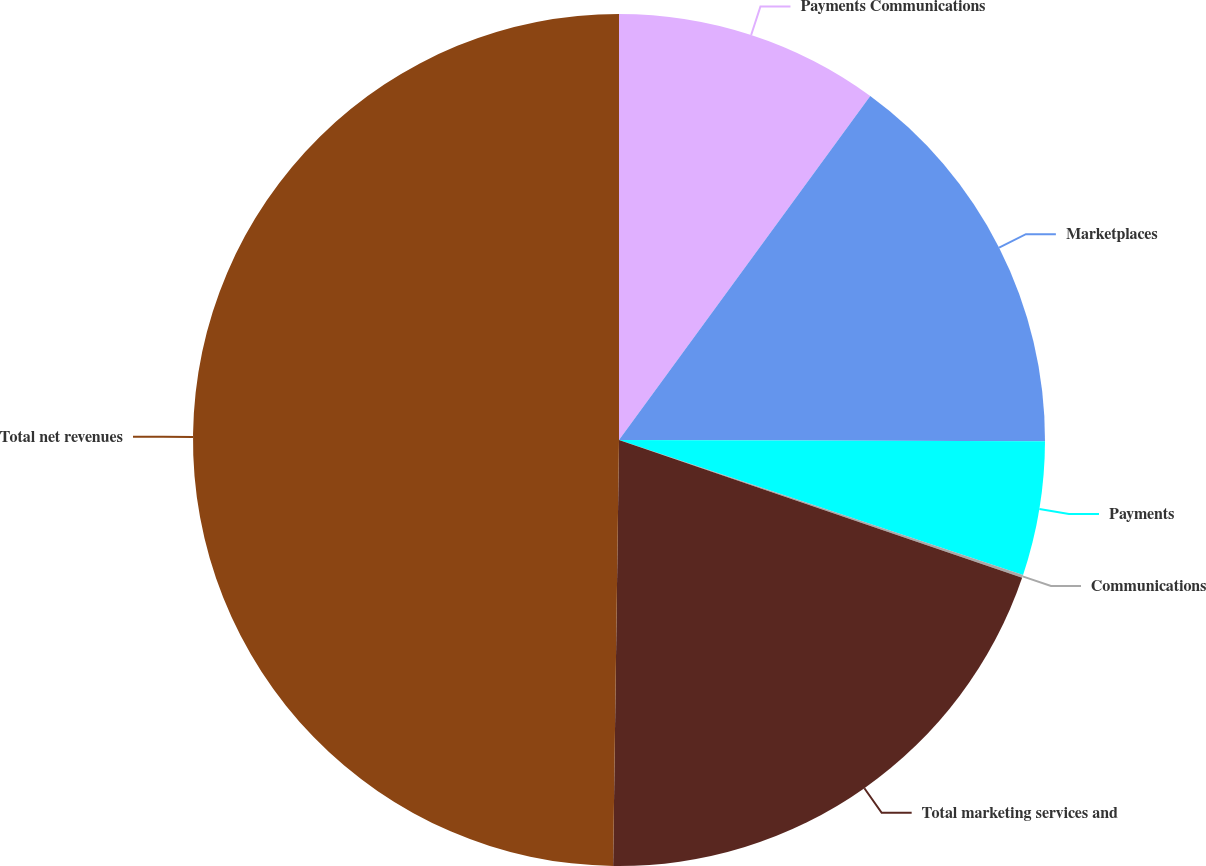Convert chart to OTSL. <chart><loc_0><loc_0><loc_500><loc_500><pie_chart><fcel>Payments Communications<fcel>Marketplaces<fcel>Payments<fcel>Communications<fcel>Total marketing services and<fcel>Total net revenues<nl><fcel>10.04%<fcel>15.01%<fcel>5.08%<fcel>0.11%<fcel>19.98%<fcel>49.78%<nl></chart> 